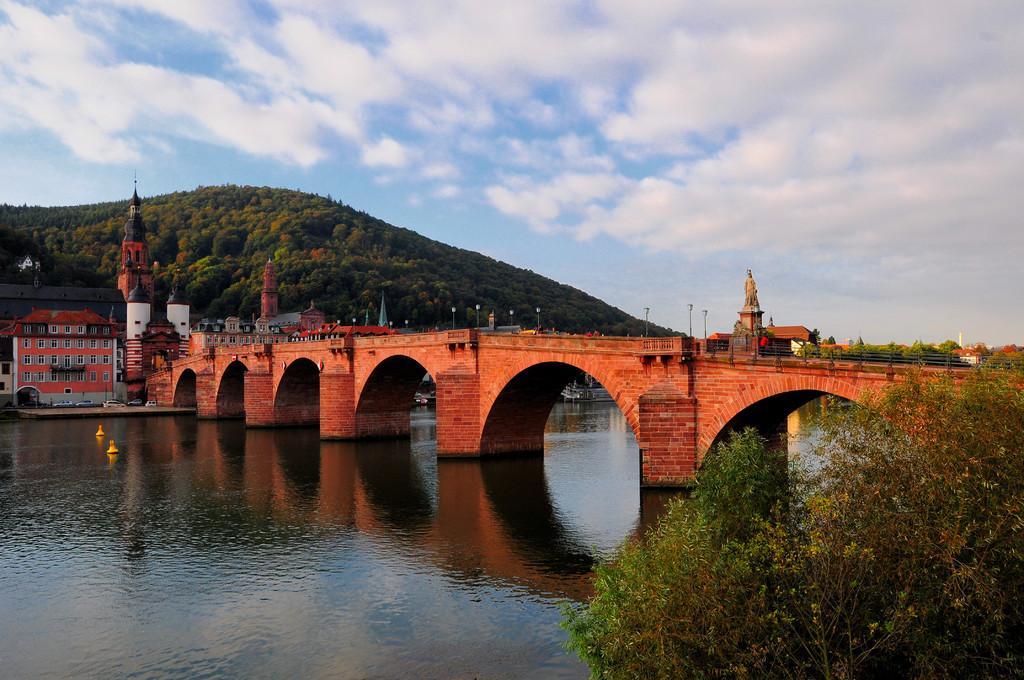Please provide a concise description of this image. In this image I can see water. There is a bridge, a statue and a hill. There are buildings, vehicles, trees,plants and in the background there is sky. 